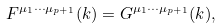Convert formula to latex. <formula><loc_0><loc_0><loc_500><loc_500>F ^ { \mu _ { 1 } \cdots \mu _ { p + 1 } } ( k ) = G ^ { \mu _ { 1 } \cdots \mu _ { p + 1 } } ( k ) ,</formula> 